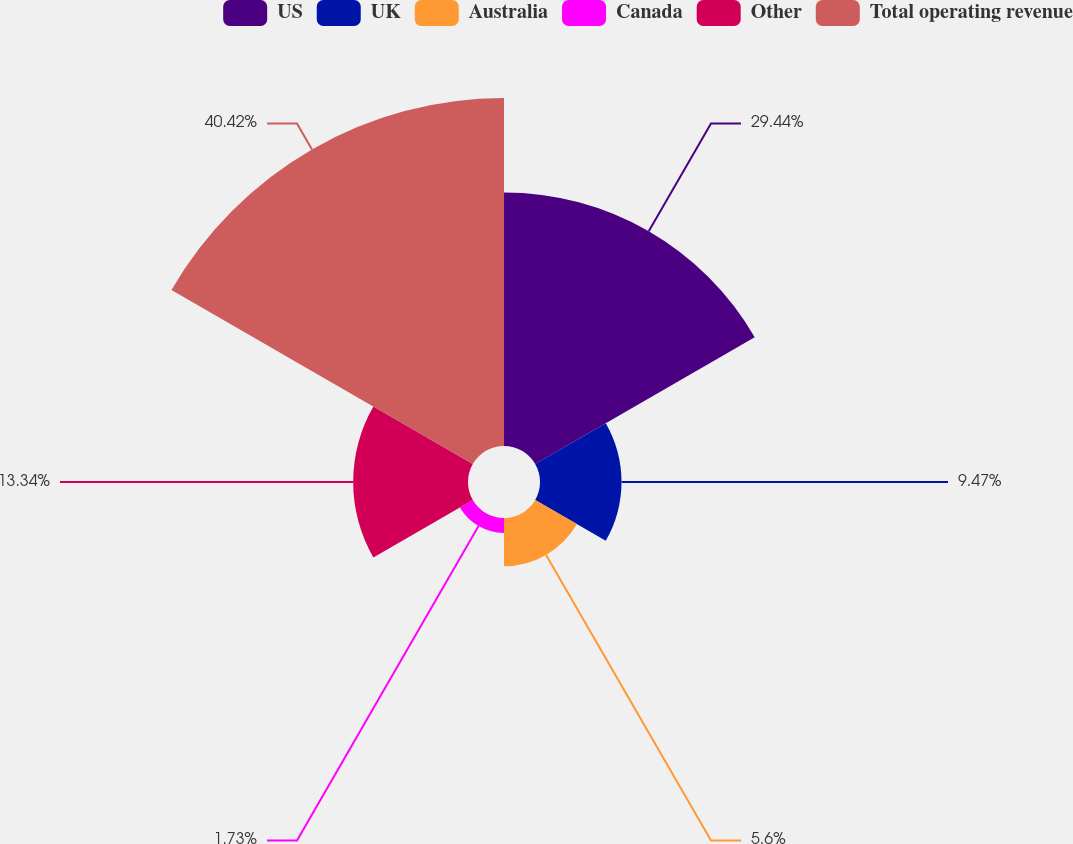Convert chart. <chart><loc_0><loc_0><loc_500><loc_500><pie_chart><fcel>US<fcel>UK<fcel>Australia<fcel>Canada<fcel>Other<fcel>Total operating revenue<nl><fcel>29.45%<fcel>9.47%<fcel>5.6%<fcel>1.73%<fcel>13.34%<fcel>40.43%<nl></chart> 